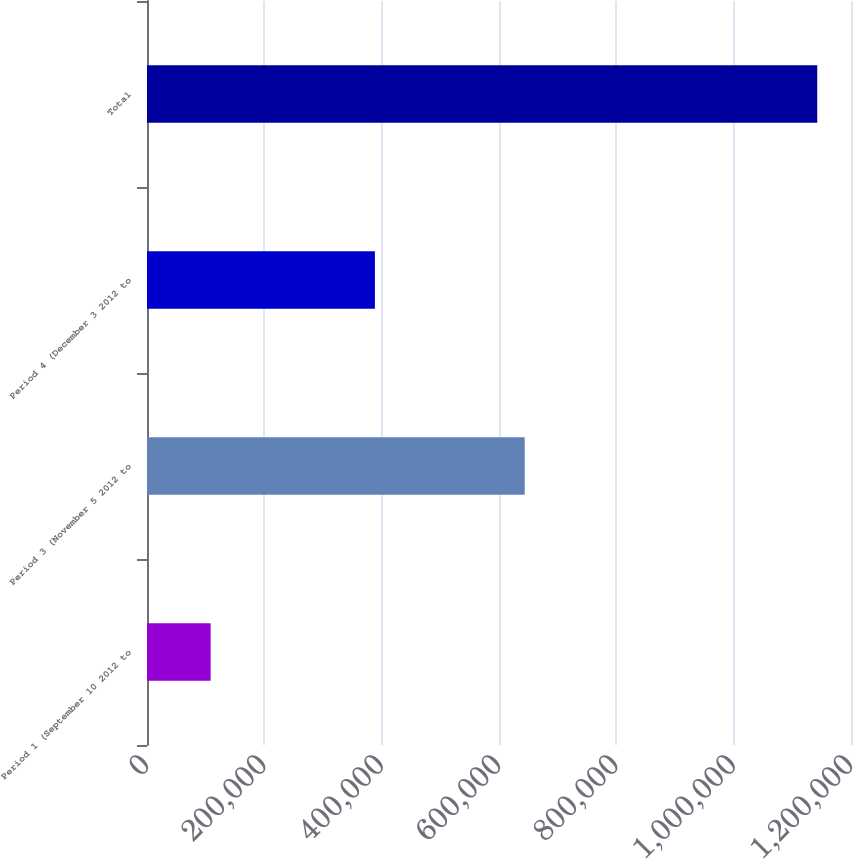Convert chart to OTSL. <chart><loc_0><loc_0><loc_500><loc_500><bar_chart><fcel>Period 1 (September 10 2012 to<fcel>Period 3 (November 5 2012 to<fcel>Period 4 (December 3 2012 to<fcel>Total<nl><fcel>108473<fcel>643853<fcel>388480<fcel>1.14245e+06<nl></chart> 